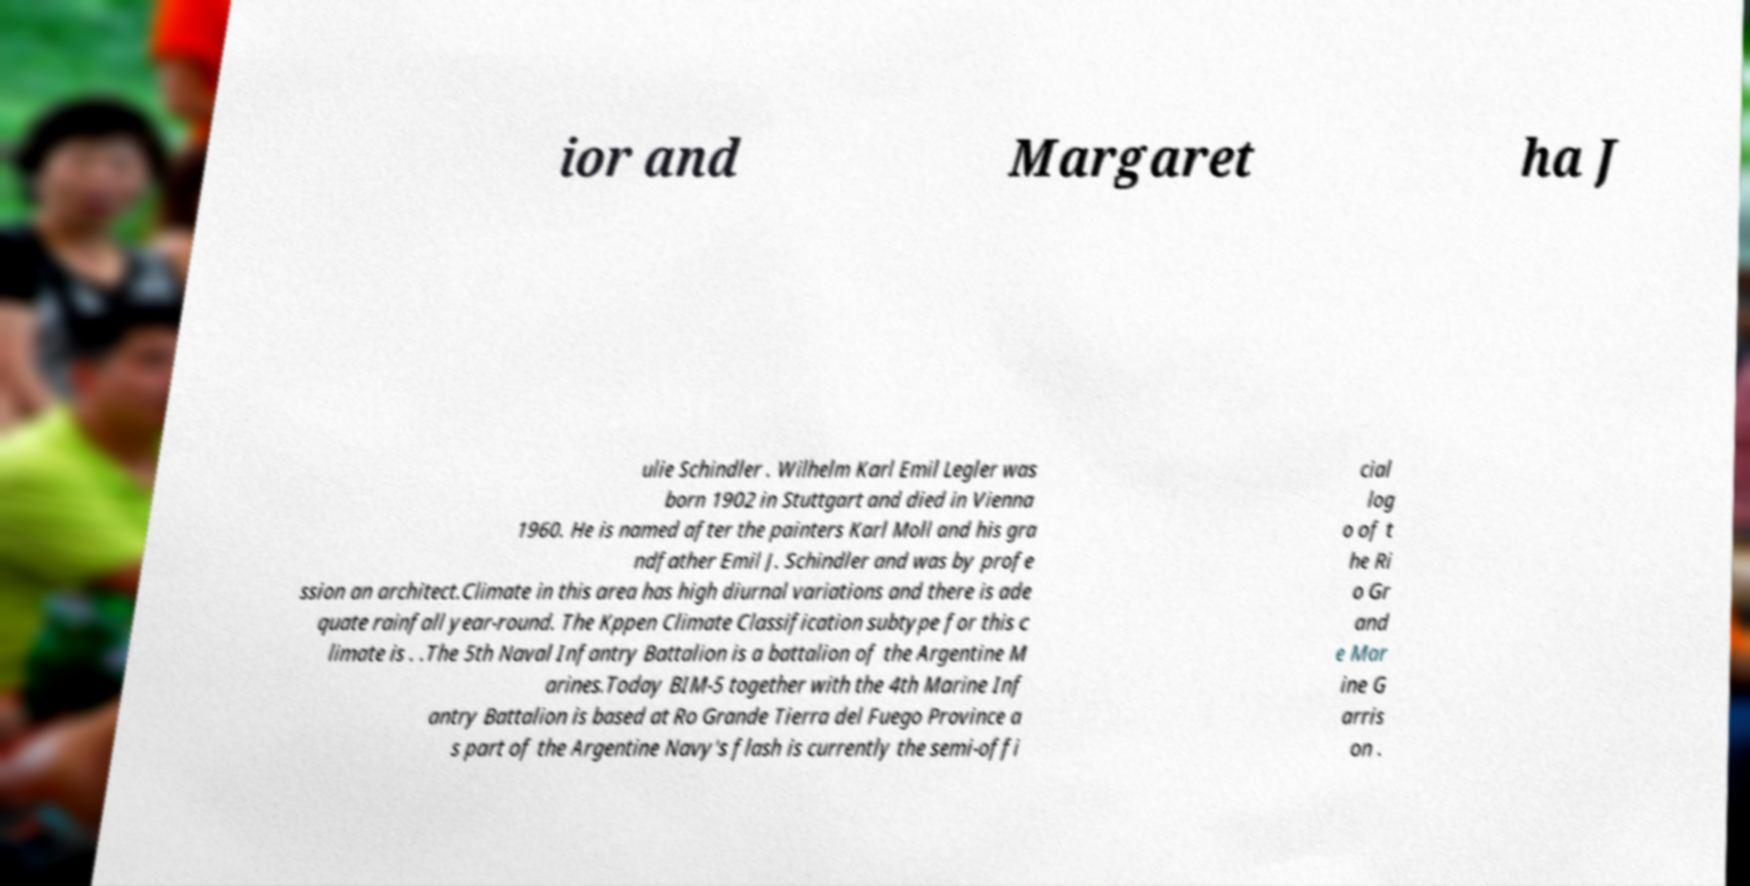Can you accurately transcribe the text from the provided image for me? ior and Margaret ha J ulie Schindler . Wilhelm Karl Emil Legler was born 1902 in Stuttgart and died in Vienna 1960. He is named after the painters Karl Moll and his gra ndfather Emil J. Schindler and was by profe ssion an architect.Climate in this area has high diurnal variations and there is ade quate rainfall year-round. The Kppen Climate Classification subtype for this c limate is . .The 5th Naval Infantry Battalion is a battalion of the Argentine M arines.Today BIM-5 together with the 4th Marine Inf antry Battalion is based at Ro Grande Tierra del Fuego Province a s part of the Argentine Navy's flash is currently the semi-offi cial log o of t he Ri o Gr and e Mar ine G arris on . 